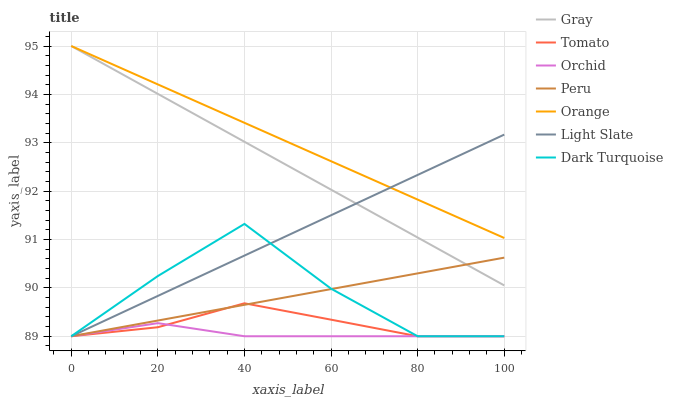Does Orchid have the minimum area under the curve?
Answer yes or no. Yes. Does Orange have the maximum area under the curve?
Answer yes or no. Yes. Does Gray have the minimum area under the curve?
Answer yes or no. No. Does Gray have the maximum area under the curve?
Answer yes or no. No. Is Orange the smoothest?
Answer yes or no. Yes. Is Dark Turquoise the roughest?
Answer yes or no. Yes. Is Gray the smoothest?
Answer yes or no. No. Is Gray the roughest?
Answer yes or no. No. Does Tomato have the lowest value?
Answer yes or no. Yes. Does Gray have the lowest value?
Answer yes or no. No. Does Orange have the highest value?
Answer yes or no. Yes. Does Light Slate have the highest value?
Answer yes or no. No. Is Orchid less than Orange?
Answer yes or no. Yes. Is Gray greater than Tomato?
Answer yes or no. Yes. Does Orchid intersect Tomato?
Answer yes or no. Yes. Is Orchid less than Tomato?
Answer yes or no. No. Is Orchid greater than Tomato?
Answer yes or no. No. Does Orchid intersect Orange?
Answer yes or no. No. 